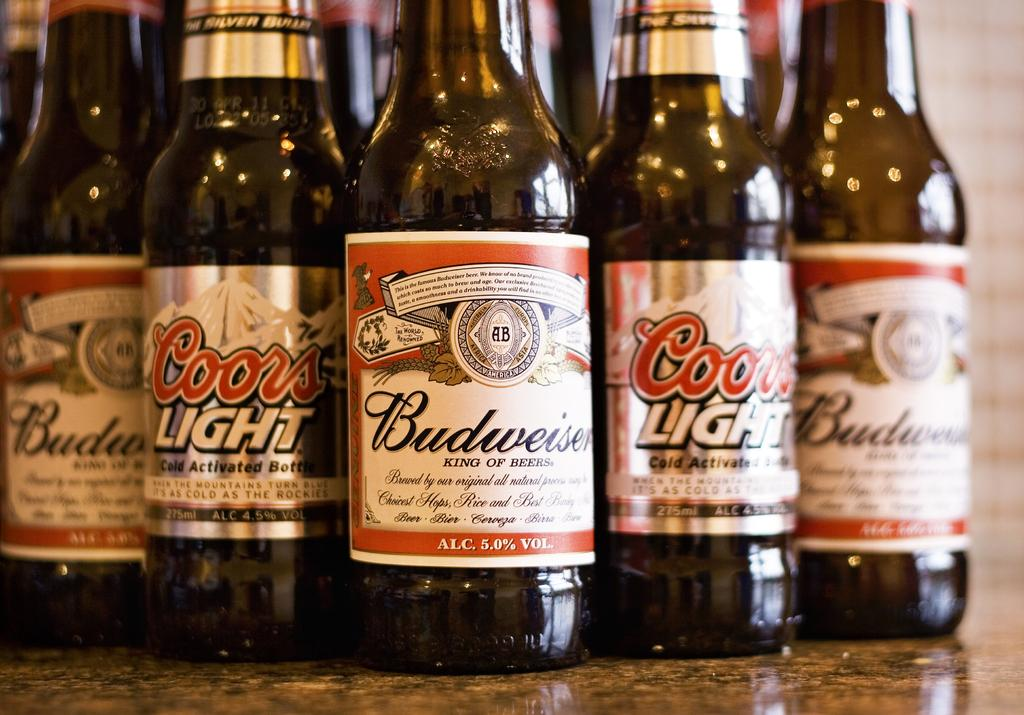Provide a one-sentence caption for the provided image. 5 bottles of beer next to each other with three of them being Budwiser and two are Coors light. 